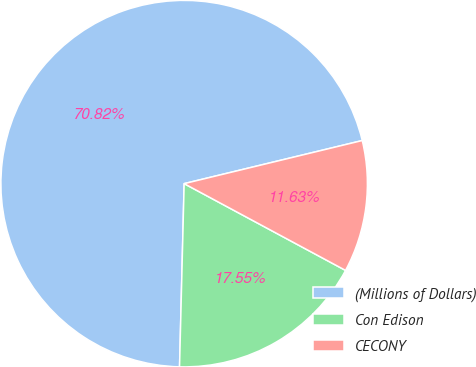<chart> <loc_0><loc_0><loc_500><loc_500><pie_chart><fcel>(Millions of Dollars)<fcel>Con Edison<fcel>CECONY<nl><fcel>70.82%<fcel>17.55%<fcel>11.63%<nl></chart> 